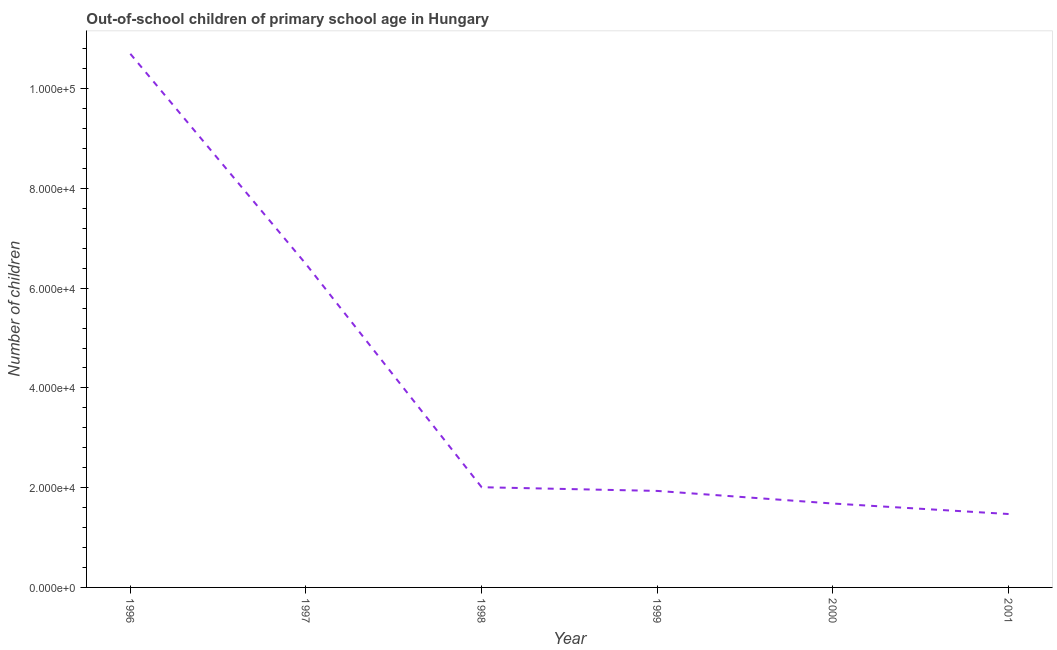What is the number of out-of-school children in 1996?
Your answer should be compact. 1.07e+05. Across all years, what is the maximum number of out-of-school children?
Keep it short and to the point. 1.07e+05. Across all years, what is the minimum number of out-of-school children?
Give a very brief answer. 1.47e+04. In which year was the number of out-of-school children maximum?
Keep it short and to the point. 1996. In which year was the number of out-of-school children minimum?
Your answer should be compact. 2001. What is the sum of the number of out-of-school children?
Make the answer very short. 2.43e+05. What is the difference between the number of out-of-school children in 1998 and 1999?
Keep it short and to the point. 743. What is the average number of out-of-school children per year?
Keep it short and to the point. 4.05e+04. What is the median number of out-of-school children?
Offer a very short reply. 1.97e+04. What is the ratio of the number of out-of-school children in 2000 to that in 2001?
Offer a terse response. 1.14. What is the difference between the highest and the second highest number of out-of-school children?
Provide a succinct answer. 4.22e+04. Is the sum of the number of out-of-school children in 1996 and 1998 greater than the maximum number of out-of-school children across all years?
Provide a short and direct response. Yes. What is the difference between the highest and the lowest number of out-of-school children?
Ensure brevity in your answer.  9.23e+04. In how many years, is the number of out-of-school children greater than the average number of out-of-school children taken over all years?
Give a very brief answer. 2. Are the values on the major ticks of Y-axis written in scientific E-notation?
Keep it short and to the point. Yes. Does the graph contain any zero values?
Your response must be concise. No. Does the graph contain grids?
Your answer should be compact. No. What is the title of the graph?
Provide a succinct answer. Out-of-school children of primary school age in Hungary. What is the label or title of the X-axis?
Ensure brevity in your answer.  Year. What is the label or title of the Y-axis?
Ensure brevity in your answer.  Number of children. What is the Number of children of 1996?
Offer a terse response. 1.07e+05. What is the Number of children of 1997?
Ensure brevity in your answer.  6.48e+04. What is the Number of children in 1998?
Offer a terse response. 2.01e+04. What is the Number of children of 1999?
Give a very brief answer. 1.93e+04. What is the Number of children in 2000?
Make the answer very short. 1.68e+04. What is the Number of children in 2001?
Offer a terse response. 1.47e+04. What is the difference between the Number of children in 1996 and 1997?
Ensure brevity in your answer.  4.22e+04. What is the difference between the Number of children in 1996 and 1998?
Give a very brief answer. 8.69e+04. What is the difference between the Number of children in 1996 and 1999?
Ensure brevity in your answer.  8.76e+04. What is the difference between the Number of children in 1996 and 2000?
Ensure brevity in your answer.  9.02e+04. What is the difference between the Number of children in 1996 and 2001?
Your response must be concise. 9.23e+04. What is the difference between the Number of children in 1997 and 1998?
Make the answer very short. 4.47e+04. What is the difference between the Number of children in 1997 and 1999?
Provide a short and direct response. 4.55e+04. What is the difference between the Number of children in 1997 and 2000?
Keep it short and to the point. 4.80e+04. What is the difference between the Number of children in 1997 and 2001?
Make the answer very short. 5.01e+04. What is the difference between the Number of children in 1998 and 1999?
Keep it short and to the point. 743. What is the difference between the Number of children in 1998 and 2000?
Give a very brief answer. 3271. What is the difference between the Number of children in 1998 and 2001?
Give a very brief answer. 5374. What is the difference between the Number of children in 1999 and 2000?
Your answer should be very brief. 2528. What is the difference between the Number of children in 1999 and 2001?
Ensure brevity in your answer.  4631. What is the difference between the Number of children in 2000 and 2001?
Give a very brief answer. 2103. What is the ratio of the Number of children in 1996 to that in 1997?
Provide a succinct answer. 1.65. What is the ratio of the Number of children in 1996 to that in 1998?
Your response must be concise. 5.33. What is the ratio of the Number of children in 1996 to that in 1999?
Keep it short and to the point. 5.53. What is the ratio of the Number of children in 1996 to that in 2000?
Ensure brevity in your answer.  6.36. What is the ratio of the Number of children in 1996 to that in 2001?
Provide a succinct answer. 7.27. What is the ratio of the Number of children in 1997 to that in 1998?
Offer a very short reply. 3.23. What is the ratio of the Number of children in 1997 to that in 1999?
Ensure brevity in your answer.  3.35. What is the ratio of the Number of children in 1997 to that in 2000?
Ensure brevity in your answer.  3.85. What is the ratio of the Number of children in 1997 to that in 2001?
Your response must be concise. 4.4. What is the ratio of the Number of children in 1998 to that in 1999?
Give a very brief answer. 1.04. What is the ratio of the Number of children in 1998 to that in 2000?
Offer a very short reply. 1.19. What is the ratio of the Number of children in 1998 to that in 2001?
Your answer should be compact. 1.36. What is the ratio of the Number of children in 1999 to that in 2000?
Provide a short and direct response. 1.15. What is the ratio of the Number of children in 1999 to that in 2001?
Make the answer very short. 1.31. What is the ratio of the Number of children in 2000 to that in 2001?
Your response must be concise. 1.14. 